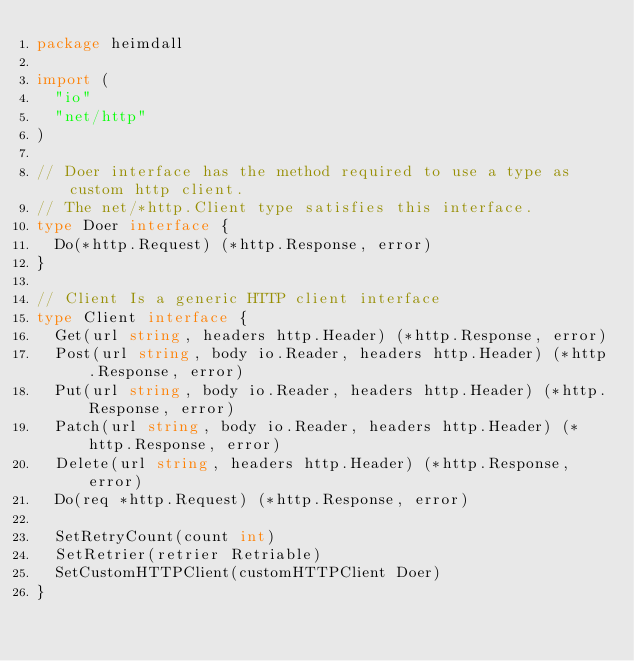Convert code to text. <code><loc_0><loc_0><loc_500><loc_500><_Go_>package heimdall

import (
	"io"
	"net/http"
)

// Doer interface has the method required to use a type as custom http client.
// The net/*http.Client type satisfies this interface.
type Doer interface {
	Do(*http.Request) (*http.Response, error)
}

// Client Is a generic HTTP client interface
type Client interface {
	Get(url string, headers http.Header) (*http.Response, error)
	Post(url string, body io.Reader, headers http.Header) (*http.Response, error)
	Put(url string, body io.Reader, headers http.Header) (*http.Response, error)
	Patch(url string, body io.Reader, headers http.Header) (*http.Response, error)
	Delete(url string, headers http.Header) (*http.Response, error)
	Do(req *http.Request) (*http.Response, error)

	SetRetryCount(count int)
	SetRetrier(retrier Retriable)
	SetCustomHTTPClient(customHTTPClient Doer)
}
</code> 